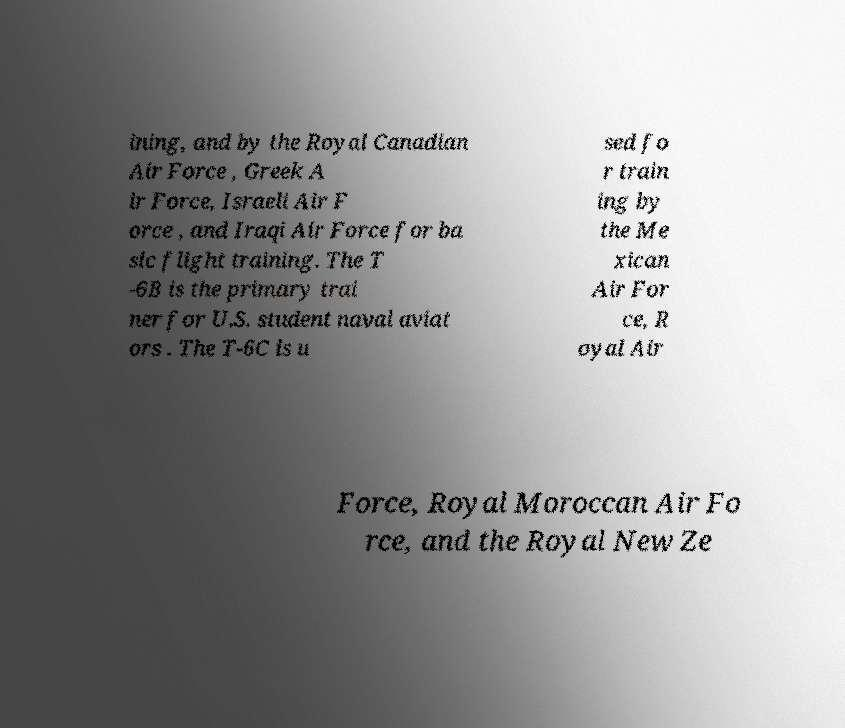What messages or text are displayed in this image? I need them in a readable, typed format. ining, and by the Royal Canadian Air Force , Greek A ir Force, Israeli Air F orce , and Iraqi Air Force for ba sic flight training. The T -6B is the primary trai ner for U.S. student naval aviat ors . The T-6C is u sed fo r train ing by the Me xican Air For ce, R oyal Air Force, Royal Moroccan Air Fo rce, and the Royal New Ze 